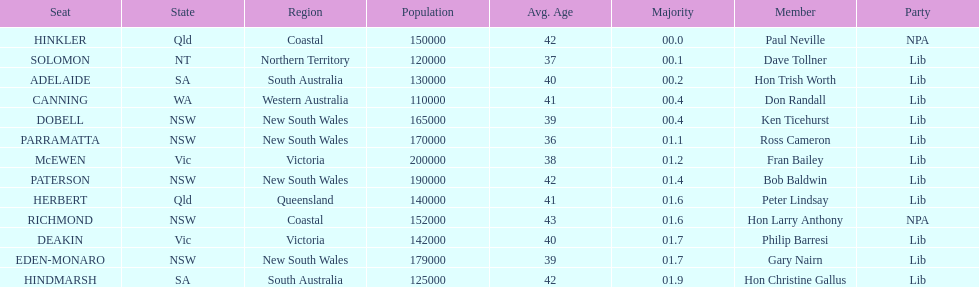Who is listed before don randall? Hon Trish Worth. 